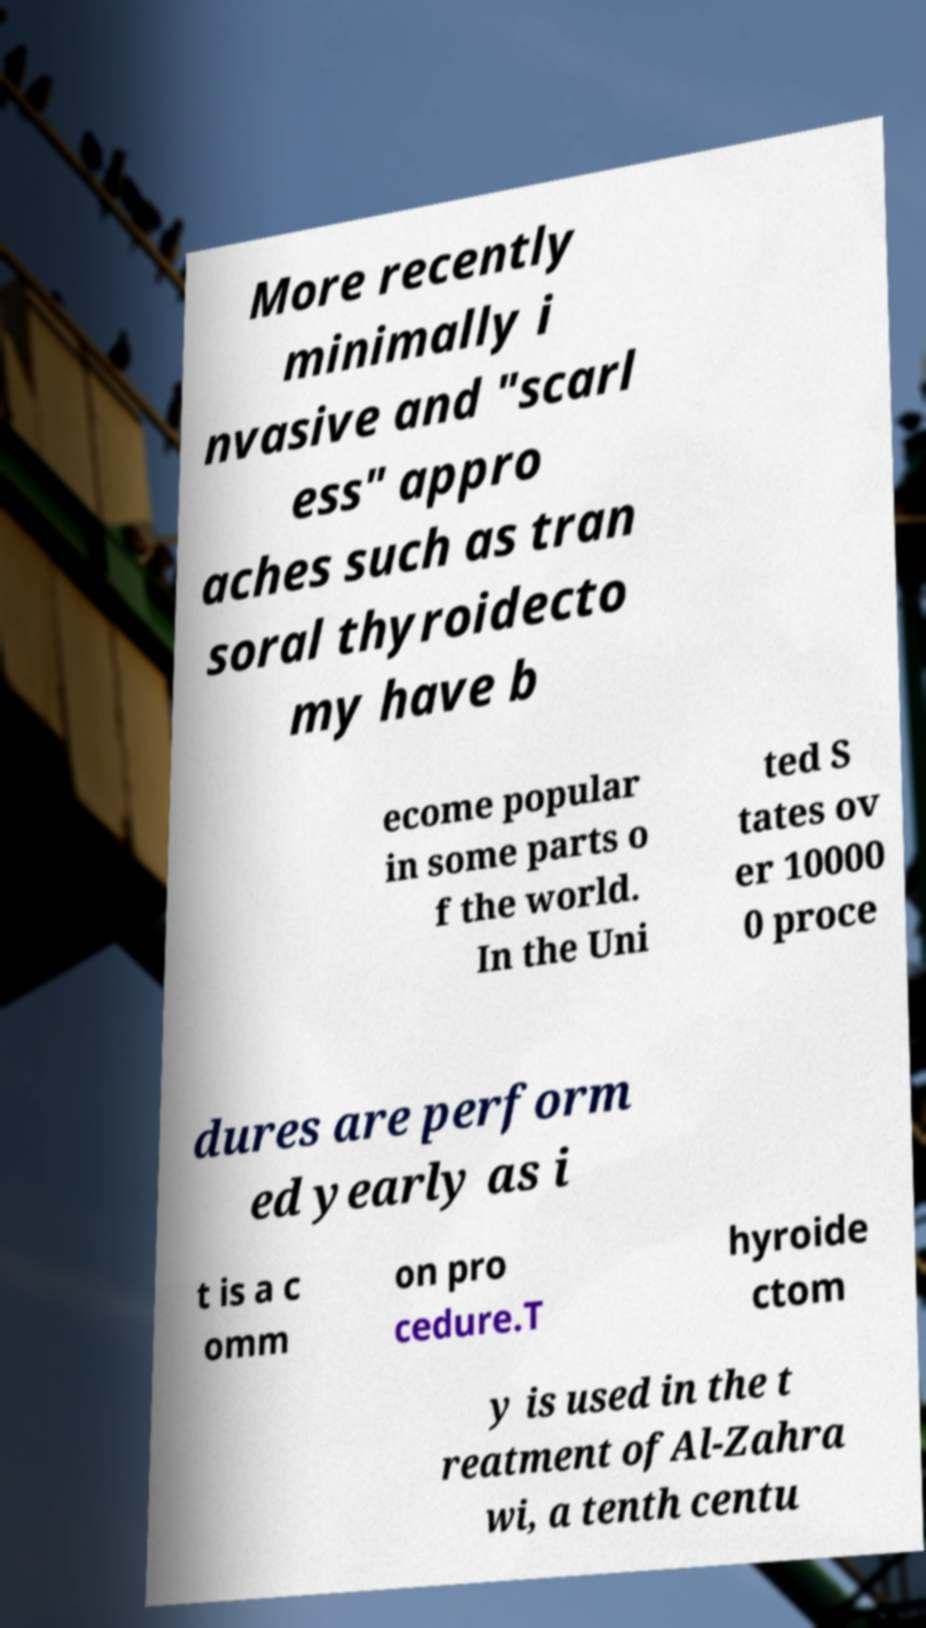Please identify and transcribe the text found in this image. More recently minimally i nvasive and "scarl ess" appro aches such as tran soral thyroidecto my have b ecome popular in some parts o f the world. In the Uni ted S tates ov er 10000 0 proce dures are perform ed yearly as i t is a c omm on pro cedure.T hyroide ctom y is used in the t reatment ofAl-Zahra wi, a tenth centu 